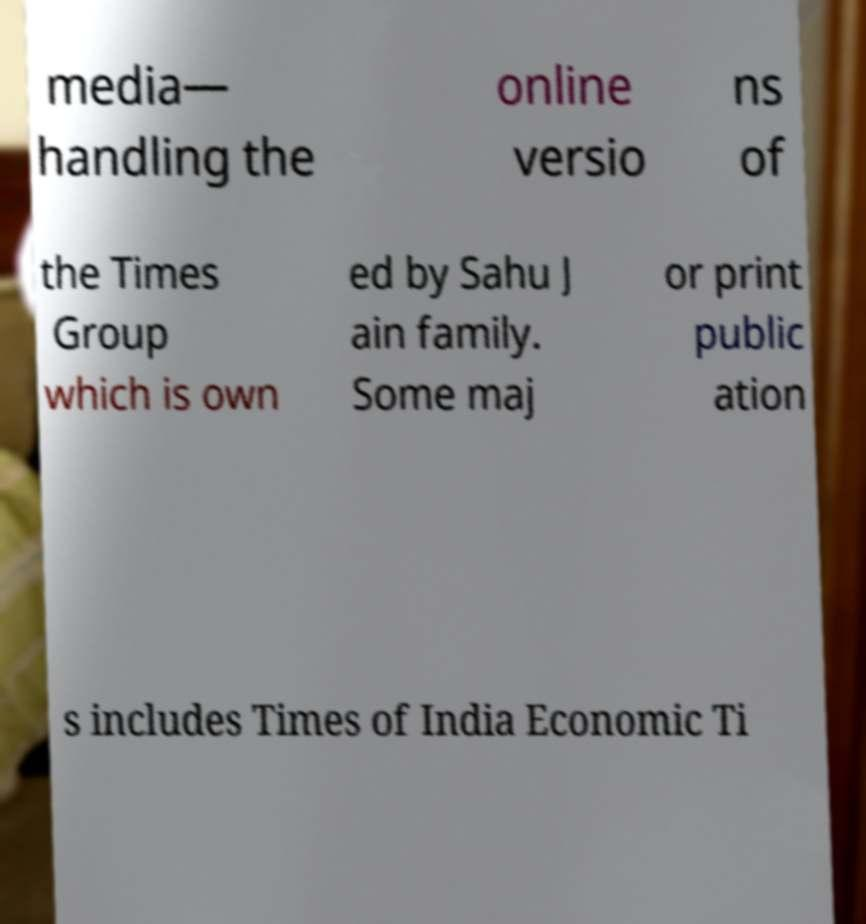Could you assist in decoding the text presented in this image and type it out clearly? media— handling the online versio ns of the Times Group which is own ed by Sahu J ain family. Some maj or print public ation s includes Times of India Economic Ti 